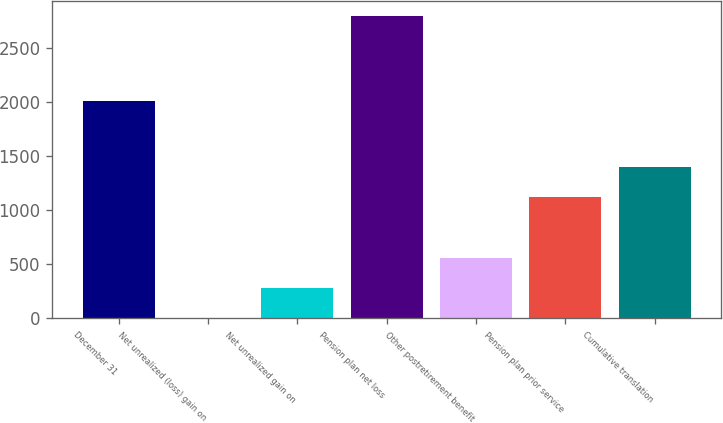<chart> <loc_0><loc_0><loc_500><loc_500><bar_chart><fcel>December 31<fcel>Net unrealized (loss) gain on<fcel>Net unrealized gain on<fcel>Pension plan net loss<fcel>Other postretirement benefit<fcel>Pension plan prior service<fcel>Cumulative translation<nl><fcel>2011<fcel>4<fcel>282.9<fcel>2793<fcel>561.8<fcel>1119.6<fcel>1398.5<nl></chart> 